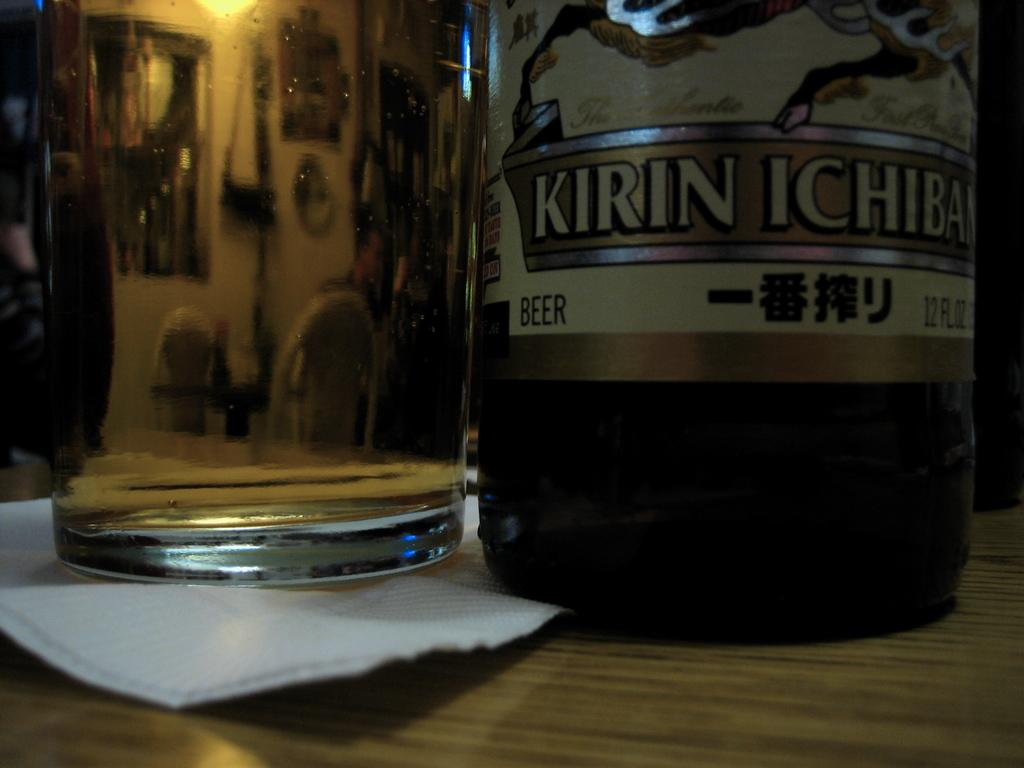What objects can be seen in the image related to beverages? There is a bottle and a glass in the image. What is the texture or material of the object in the image that can be used for wiping? The tissue paper in the image is used for wiping. What can be seen in the reflections of the glass in the image? The glass has reflections of chairs, a wall, a frame, and a light. Can you see an airplane flying over the road in the image? There is no airplane or road present in the image. What note is written on the tissue paper in the image? There is no note written on the tissue paper in the image. 